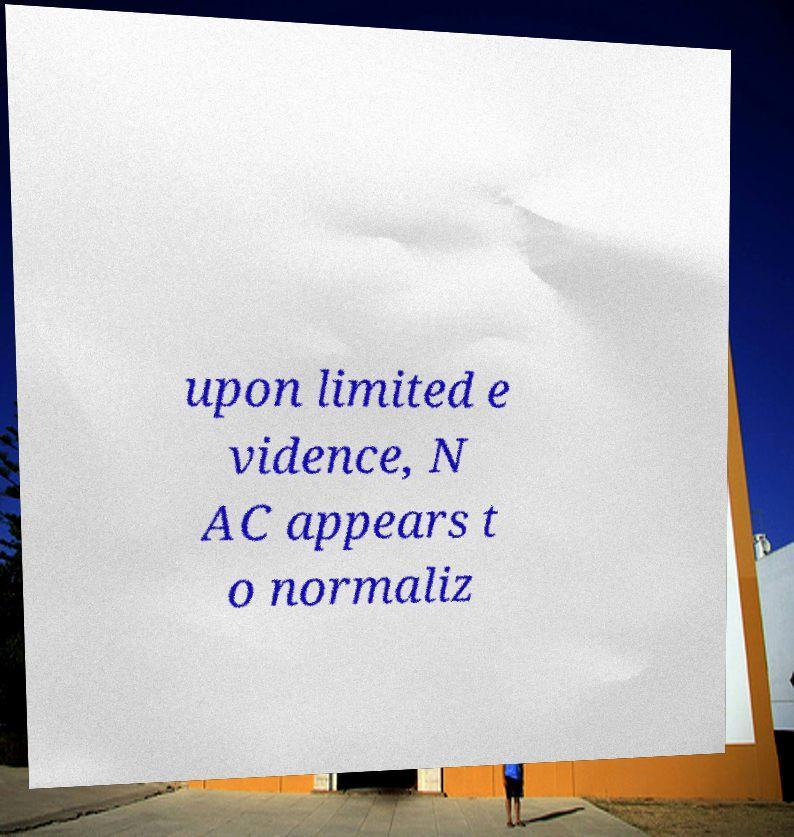For documentation purposes, I need the text within this image transcribed. Could you provide that? upon limited e vidence, N AC appears t o normaliz 